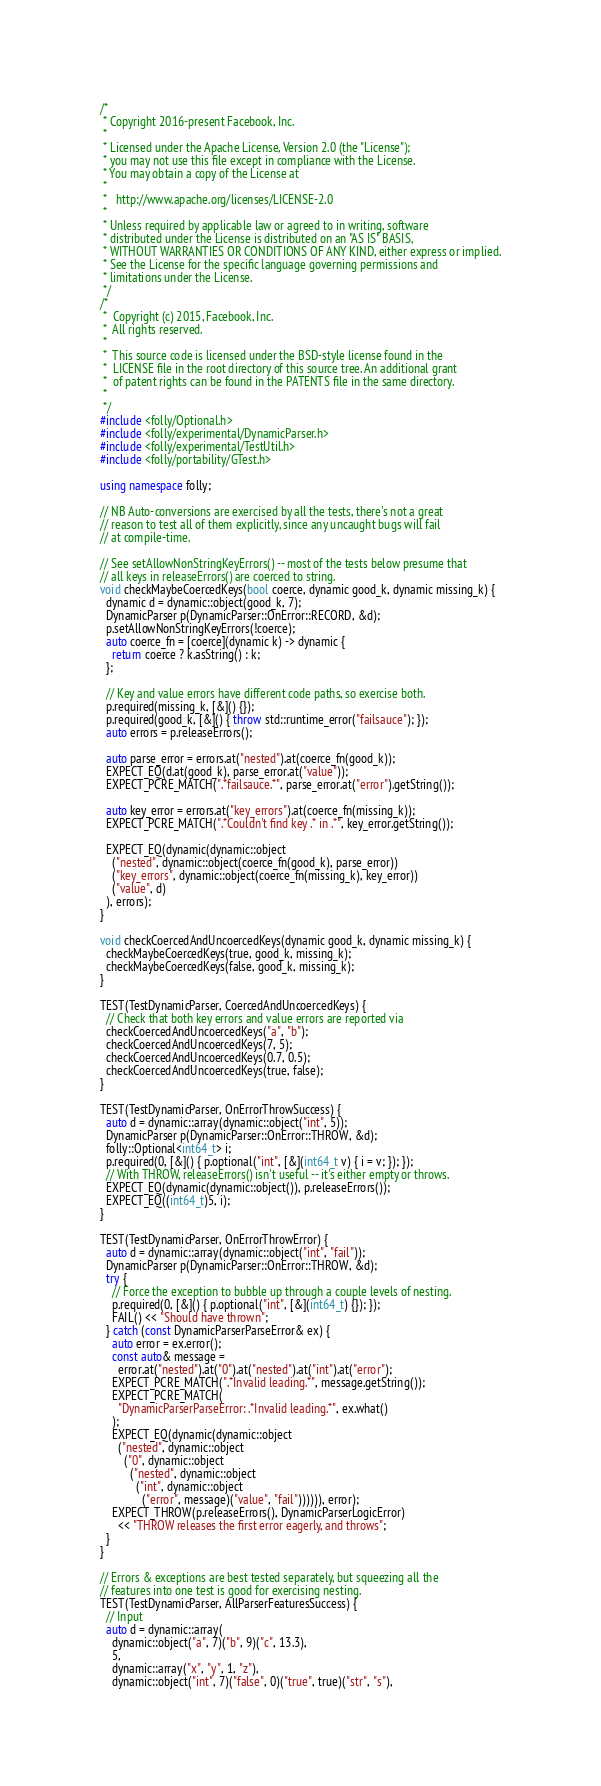<code> <loc_0><loc_0><loc_500><loc_500><_C++_>/*
 * Copyright 2016-present Facebook, Inc.
 *
 * Licensed under the Apache License, Version 2.0 (the "License");
 * you may not use this file except in compliance with the License.
 * You may obtain a copy of the License at
 *
 *   http://www.apache.org/licenses/LICENSE-2.0
 *
 * Unless required by applicable law or agreed to in writing, software
 * distributed under the License is distributed on an "AS IS" BASIS,
 * WITHOUT WARRANTIES OR CONDITIONS OF ANY KIND, either express or implied.
 * See the License for the specific language governing permissions and
 * limitations under the License.
 */
/*
 *  Copyright (c) 2015, Facebook, Inc.
 *  All rights reserved.
 *
 *  This source code is licensed under the BSD-style license found in the
 *  LICENSE file in the root directory of this source tree. An additional grant
 *  of patent rights can be found in the PATENTS file in the same directory.
 *
 */
#include <folly/Optional.h>
#include <folly/experimental/DynamicParser.h>
#include <folly/experimental/TestUtil.h>
#include <folly/portability/GTest.h>

using namespace folly;

// NB Auto-conversions are exercised by all the tests, there's not a great
// reason to test all of them explicitly, since any uncaught bugs will fail
// at compile-time.

// See setAllowNonStringKeyErrors() -- most of the tests below presume that
// all keys in releaseErrors() are coerced to string.
void checkMaybeCoercedKeys(bool coerce, dynamic good_k, dynamic missing_k) {
  dynamic d = dynamic::object(good_k, 7);
  DynamicParser p(DynamicParser::OnError::RECORD, &d);
  p.setAllowNonStringKeyErrors(!coerce);
  auto coerce_fn = [coerce](dynamic k) -> dynamic {
    return coerce ? k.asString() : k;
  };

  // Key and value errors have different code paths, so exercise both.
  p.required(missing_k, [&]() {});
  p.required(good_k, [&]() { throw std::runtime_error("failsauce"); });
  auto errors = p.releaseErrors();

  auto parse_error = errors.at("nested").at(coerce_fn(good_k));
  EXPECT_EQ(d.at(good_k), parse_error.at("value"));
  EXPECT_PCRE_MATCH(".*failsauce.*", parse_error.at("error").getString());

  auto key_error = errors.at("key_errors").at(coerce_fn(missing_k));
  EXPECT_PCRE_MATCH(".*Couldn't find key .* in .*", key_error.getString());

  EXPECT_EQ(dynamic(dynamic::object
    ("nested", dynamic::object(coerce_fn(good_k), parse_error))
    ("key_errors", dynamic::object(coerce_fn(missing_k), key_error))
    ("value", d)
  ), errors);
}

void checkCoercedAndUncoercedKeys(dynamic good_k, dynamic missing_k) {
  checkMaybeCoercedKeys(true, good_k, missing_k);
  checkMaybeCoercedKeys(false, good_k, missing_k);
}

TEST(TestDynamicParser, CoercedAndUncoercedKeys) {
  // Check that both key errors and value errors are reported via
  checkCoercedAndUncoercedKeys("a", "b");
  checkCoercedAndUncoercedKeys(7, 5);
  checkCoercedAndUncoercedKeys(0.7, 0.5);
  checkCoercedAndUncoercedKeys(true, false);
}

TEST(TestDynamicParser, OnErrorThrowSuccess) {
  auto d = dynamic::array(dynamic::object("int", 5));
  DynamicParser p(DynamicParser::OnError::THROW, &d);
  folly::Optional<int64_t> i;
  p.required(0, [&]() { p.optional("int", [&](int64_t v) { i = v; }); });
  // With THROW, releaseErrors() isn't useful -- it's either empty or throws.
  EXPECT_EQ(dynamic(dynamic::object()), p.releaseErrors());
  EXPECT_EQ((int64_t)5, i);
}

TEST(TestDynamicParser, OnErrorThrowError) {
  auto d = dynamic::array(dynamic::object("int", "fail"));
  DynamicParser p(DynamicParser::OnError::THROW, &d);
  try {
    // Force the exception to bubble up through a couple levels of nesting.
    p.required(0, [&]() { p.optional("int", [&](int64_t) {}); });
    FAIL() << "Should have thrown";
  } catch (const DynamicParserParseError& ex) {
    auto error = ex.error();
    const auto& message =
      error.at("nested").at("0").at("nested").at("int").at("error");
    EXPECT_PCRE_MATCH(".*Invalid leading.*", message.getString());
    EXPECT_PCRE_MATCH(
      "DynamicParserParseError: .*Invalid leading.*", ex.what()
    );
    EXPECT_EQ(dynamic(dynamic::object
      ("nested", dynamic::object
        ("0", dynamic::object
          ("nested", dynamic::object
            ("int", dynamic::object
              ("error", message)("value", "fail")))))), error);
    EXPECT_THROW(p.releaseErrors(), DynamicParserLogicError)
      << "THROW releases the first error eagerly, and throws";
  }
}

// Errors & exceptions are best tested separately, but squeezing all the
// features into one test is good for exercising nesting.
TEST(TestDynamicParser, AllParserFeaturesSuccess) {
  // Input
  auto d = dynamic::array(
    dynamic::object("a", 7)("b", 9)("c", 13.3),
    5,
    dynamic::array("x", "y", 1, "z"),
    dynamic::object("int", 7)("false", 0)("true", true)("str", "s"),</code> 